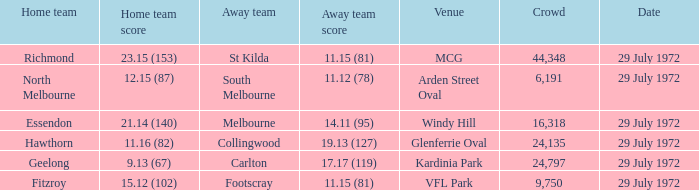When collingwood was the away team, what was the home team? Hawthorn. 